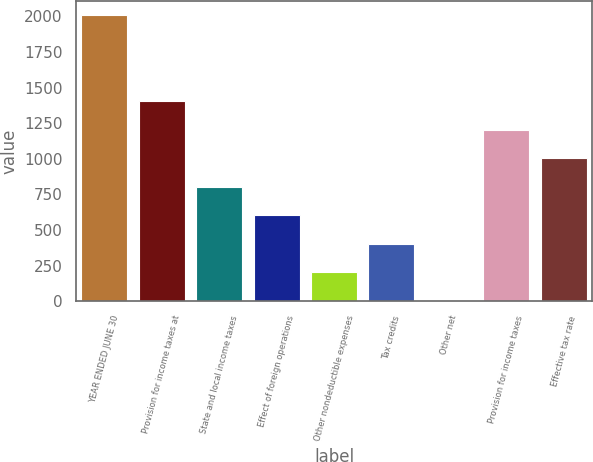Convert chart. <chart><loc_0><loc_0><loc_500><loc_500><bar_chart><fcel>YEAR ENDED JUNE 30<fcel>Provision for income taxes at<fcel>State and local income taxes<fcel>Effect of foreign operations<fcel>Other nondeductible expenses<fcel>Tax credits<fcel>Other net<fcel>Provision for income taxes<fcel>Effective tax rate<nl><fcel>2008<fcel>1406.17<fcel>804.34<fcel>603.73<fcel>202.51<fcel>403.12<fcel>1.9<fcel>1205.56<fcel>1004.95<nl></chart> 